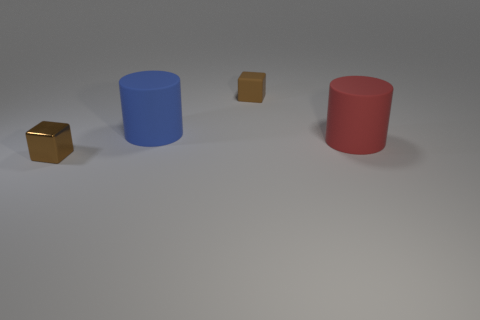Add 1 cylinders. How many objects exist? 5 Subtract all blue cylinders. How many cylinders are left? 1 Subtract 2 cubes. How many cubes are left? 0 Subtract all red cylinders. Subtract all brown spheres. How many cylinders are left? 1 Subtract all blue balls. How many red cylinders are left? 1 Subtract all large gray metal objects. Subtract all large rubber objects. How many objects are left? 2 Add 2 metal things. How many metal things are left? 3 Add 2 large blue matte objects. How many large blue matte objects exist? 3 Subtract 0 brown cylinders. How many objects are left? 4 